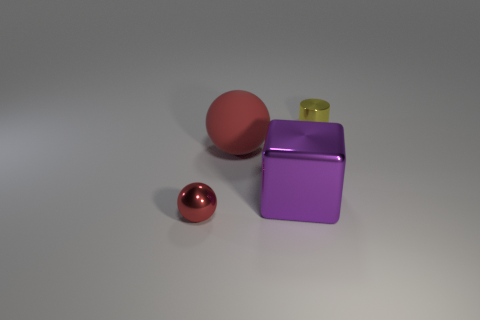Is there a sense of depth in the image, and if so, how is it achieved? Yes, there is a sense of depth in the image, created by the relative sizes of the objects, their overlapping positions, and the shadows they cast on the surface. These visual cues give the viewer an understanding of how the objects are positioned in three-dimensional space. Can you comment on the perspective from which the image is taken? The image is taken from a slightly elevated angle, looking down upon the objects. This perspective allows the viewer to see the tops and sides of the objects clearly, providing a comprehensive view of their shapes and relative positions. 